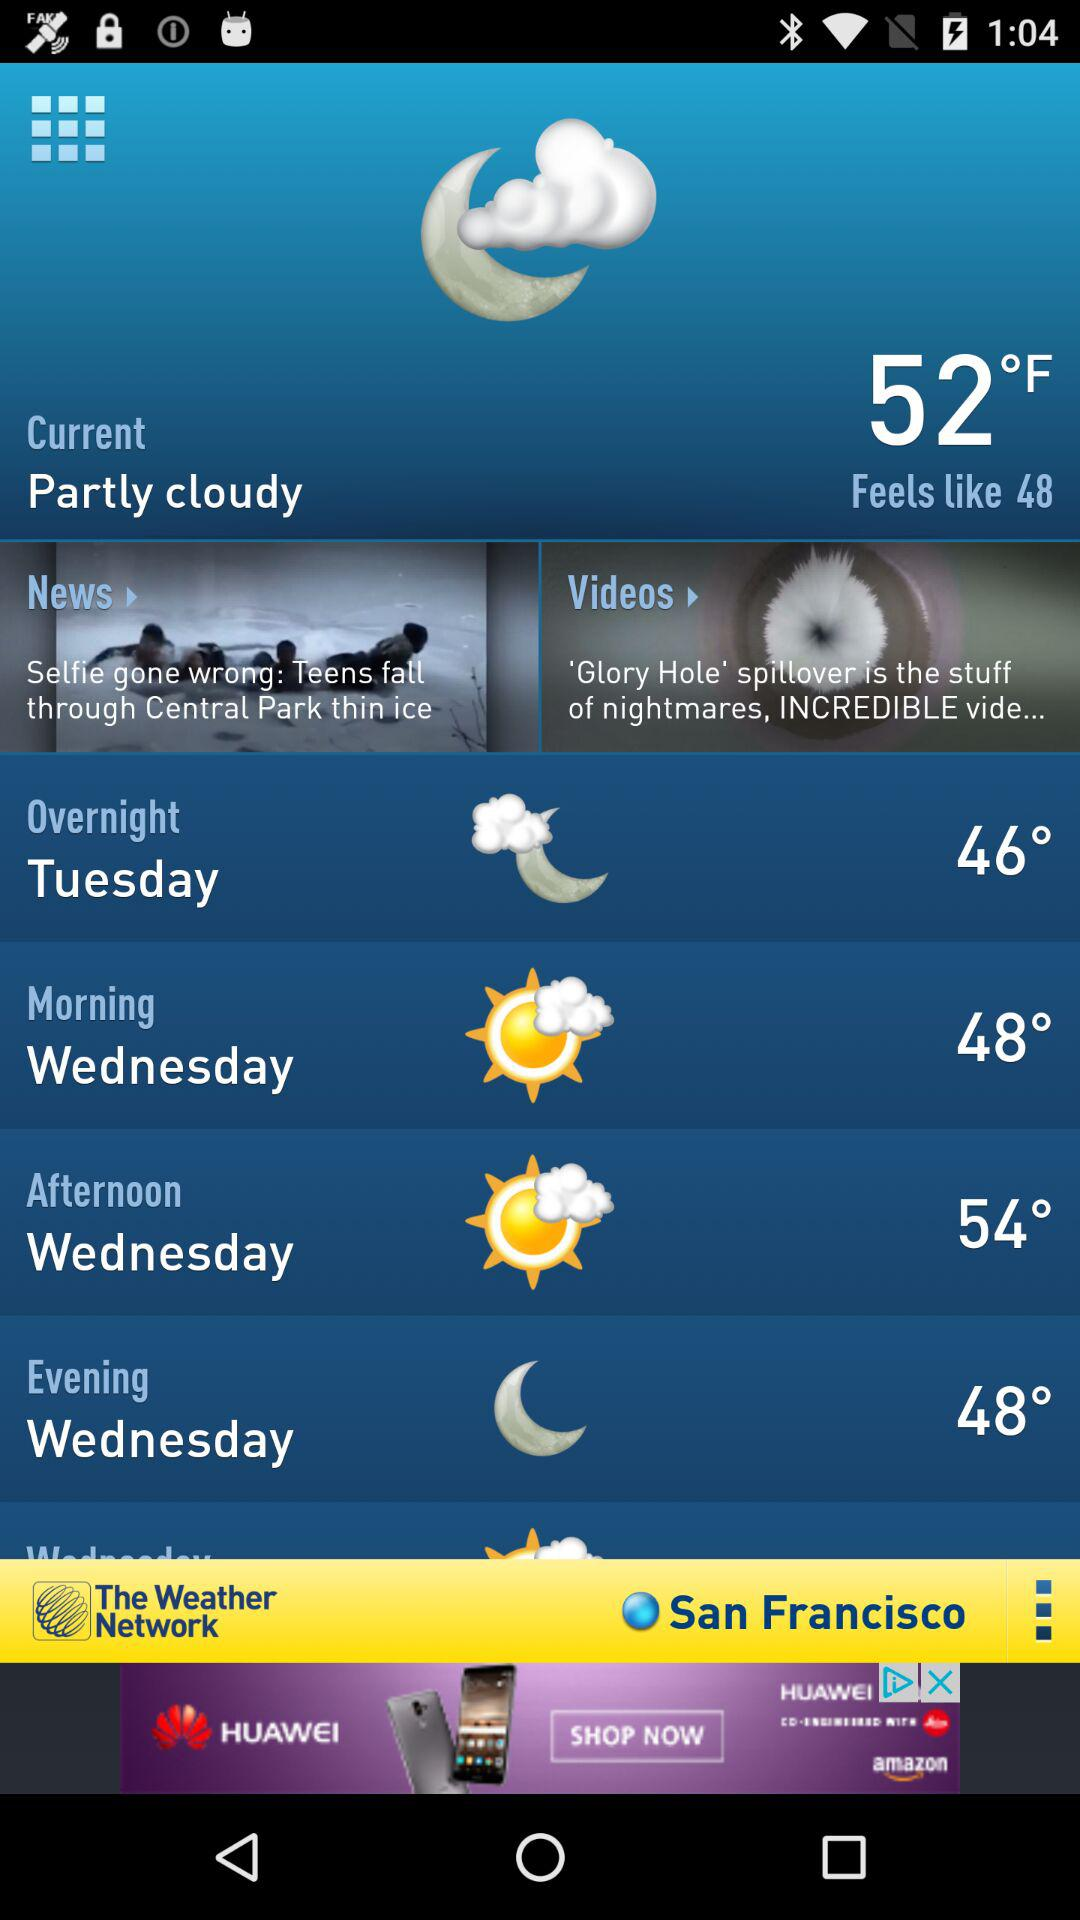What is the present temperature? The present temperature is 52°F. 